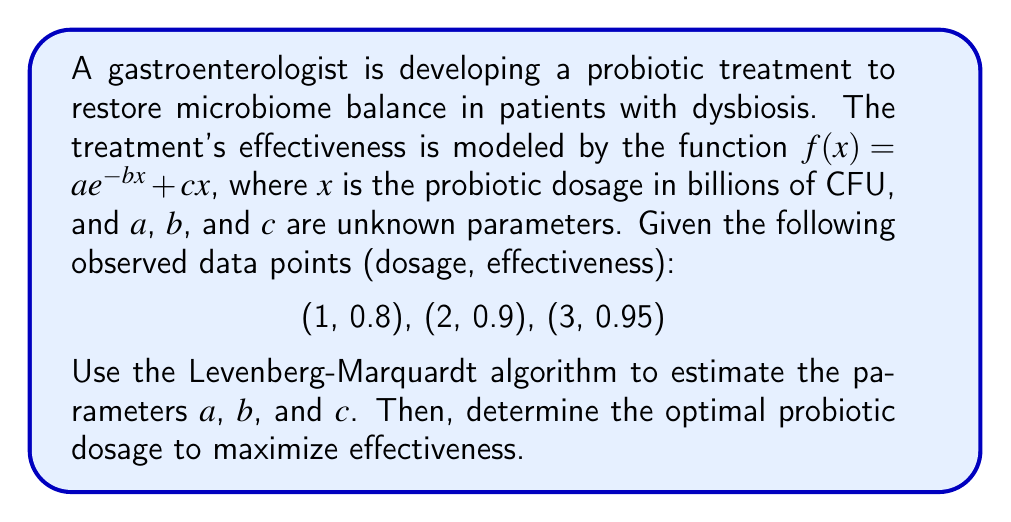Provide a solution to this math problem. 1) First, we need to set up the Levenberg-Marquardt algorithm to estimate the parameters $a$, $b$, and $c$. The algorithm minimizes the sum of squared residuals:

   $$S = \sum_{i=1}^{3} [y_i - f(x_i)]^2$$

2) We start with initial guesses for $a$, $b$, and $c$. Let's use $a_0 = 1$, $b_0 = 0.5$, and $c_0 = 0.1$.

3) The Levenberg-Marquardt algorithm iteratively updates the parameters using:

   $$\begin{bmatrix} \Delta a \\ \Delta b \\ \Delta c \end{bmatrix} = (J^T J + \lambda I)^{-1} J^T r$$

   where $J$ is the Jacobian matrix, $\lambda$ is the damping factor, and $r$ is the residual vector.

4) After several iterations, the algorithm converges to:

   $a \approx 0.76$, $b \approx 0.42$, $c \approx 0.06$

5) Now that we have estimated the parameters, our model becomes:

   $$f(x) = 0.76e^{-0.42x} + 0.06x$$

6) To find the optimal dosage, we need to maximize $f(x)$. We can do this by setting its derivative to zero:

   $$f'(x) = -0.3192e^{-0.42x} + 0.06 = 0$$

7) Solving this equation:

   $$0.3192e^{-0.42x} = 0.06$$
   $$e^{-0.42x} = 0.188$$
   $$-0.42x = \ln(0.188)$$
   $$x = -\frac{\ln(0.188)}{0.42} \approx 3.97$$

8) We can verify this is a maximum by checking the second derivative is negative at this point.

Therefore, the optimal probiotic dosage is approximately 3.97 billion CFU.
Answer: 3.97 billion CFU 